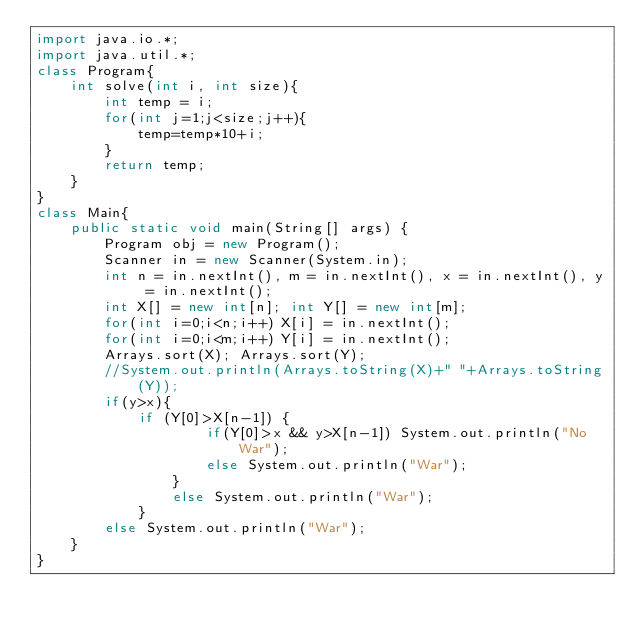<code> <loc_0><loc_0><loc_500><loc_500><_Java_>import java.io.*;
import java.util.*;
class Program{
    int solve(int i, int size){
        int temp = i;
        for(int j=1;j<size;j++){
            temp=temp*10+i;
        }
        return temp;
    }
}
class Main{
    public static void main(String[] args) {
        Program obj = new Program();
        Scanner in = new Scanner(System.in);
        int n = in.nextInt(), m = in.nextInt(), x = in.nextInt(), y = in.nextInt();
        int X[] = new int[n]; int Y[] = new int[m];
        for(int i=0;i<n;i++) X[i] = in.nextInt();
        for(int i=0;i<m;i++) Y[i] = in.nextInt();
        Arrays.sort(X); Arrays.sort(Y);
        //System.out.println(Arrays.toString(X)+" "+Arrays.toString(Y));
        if(y>x){
            if (Y[0]>X[n-1]) {
                    if(Y[0]>x && y>X[n-1]) System.out.println("No War");
                    else System.out.println("War");
                }
                else System.out.println("War");
            }
        else System.out.println("War");
    }
}</code> 